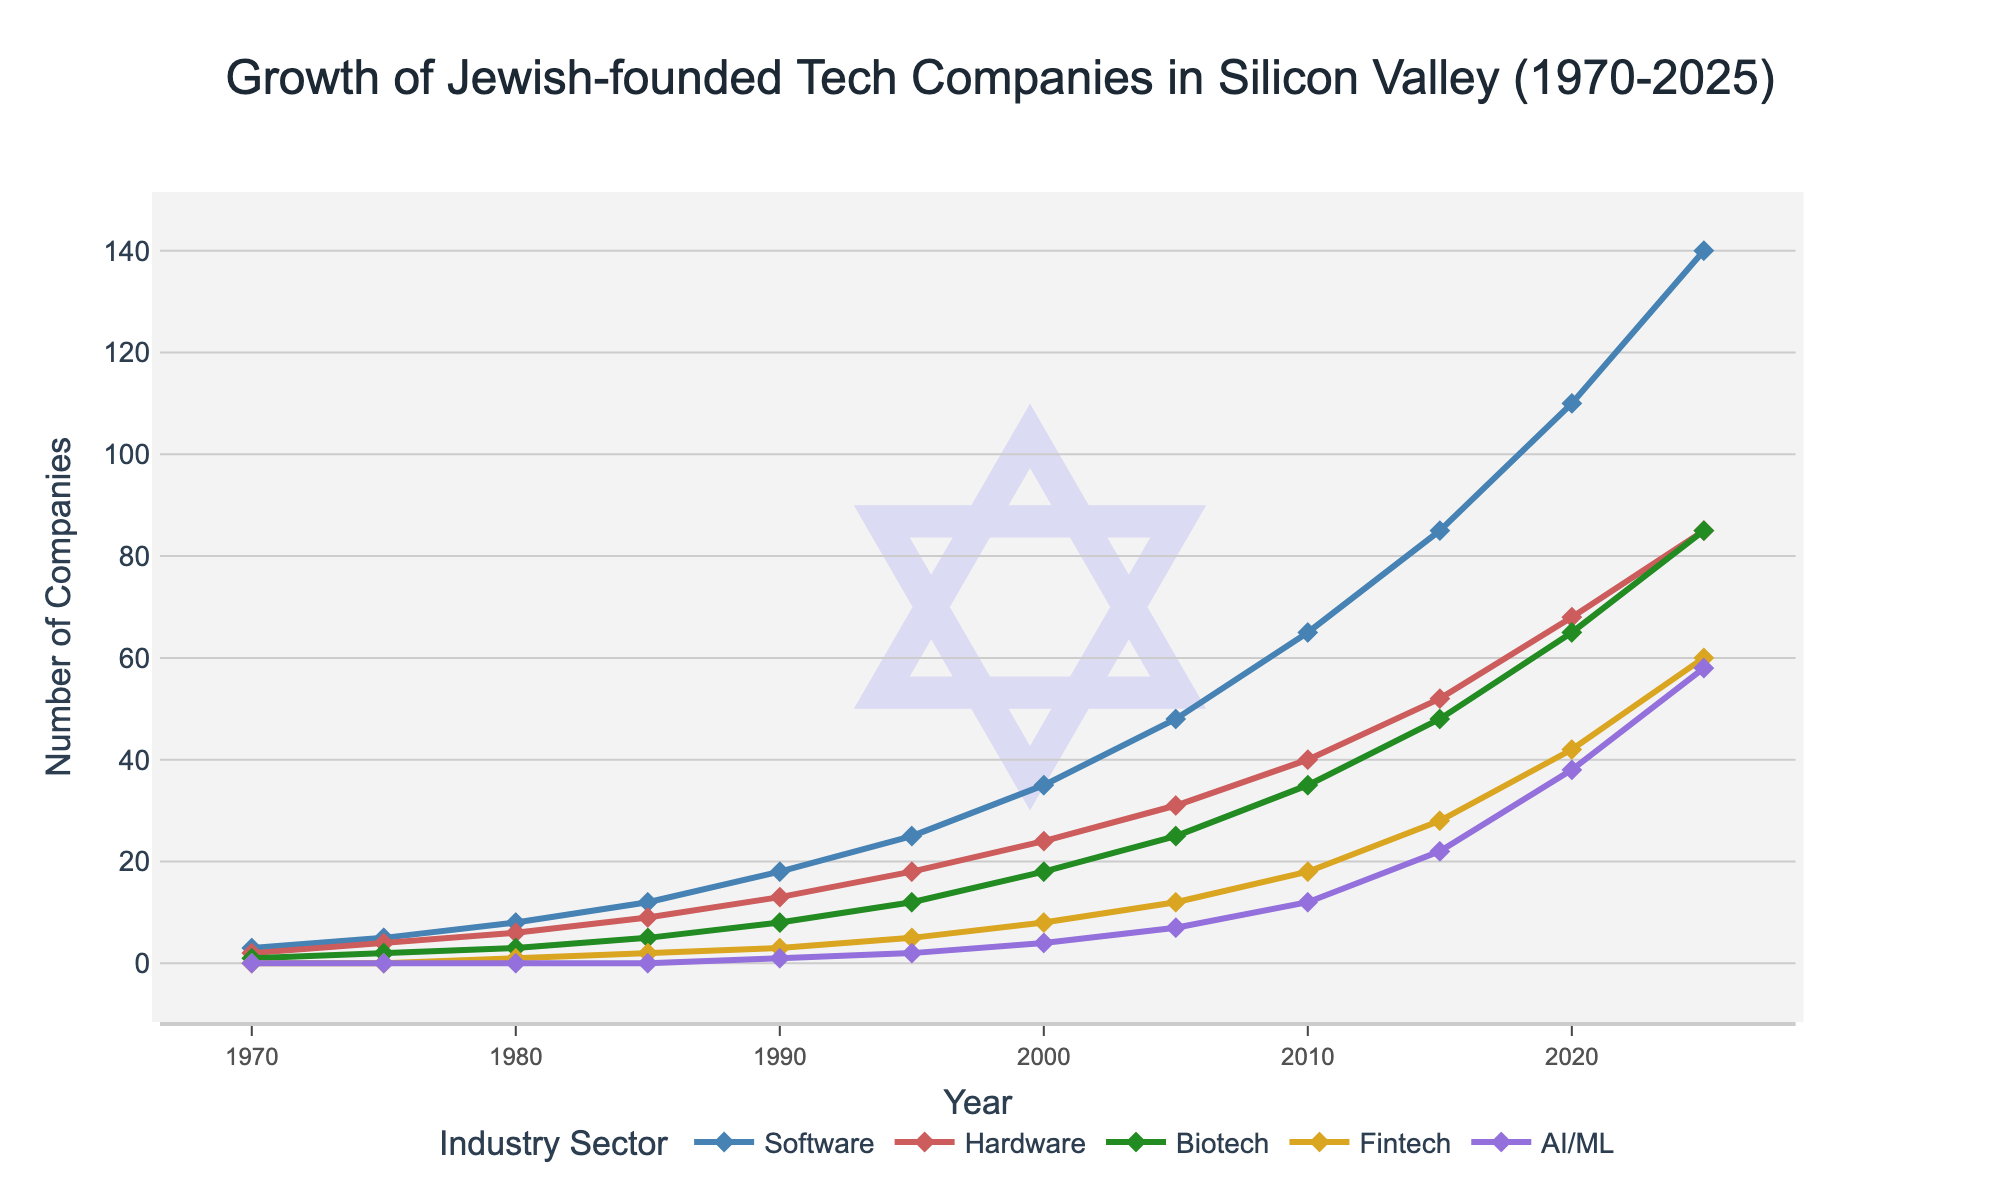What is the trend for software companies from 1970 to 2025? The software companies show a clear increasing trend from 1970 to 2025. In 1970, there are only 3 companies, while by 2025, the number reaches 140. This continuous growth indicates a steady expansion in the number of Jewish-founded software companies over the years.
Answer: Increasing trend How many sectors were represented by Jewish-founded companies in 1980? By visually detecting the presence of lines in 1980, we see markers for Software, Hardware, Biotech, and Fintech. The AI/ML sector starts later, and thus is absent. Summing up, 4 sectors were present: Software, Hardware, Biotech, and Fintech.
Answer: 4 Which industry sector had the highest growth rate from 2000 to 2025? By comparing the slopes of the lines from 2000 to 2025, AI/ML had the steepest increase in numbers (from 4 to 58), indicating the highest growth rate.
Answer: AI/ML Compare the number of hardware and biotech companies in 2010. In the year 2010, the number of hardware companies is 40 and the number of biotech companies is 35. Comparing these numbers, there are more hardware companies than biotech companies in 2010.
Answer: Hardware (40 vs 35) What is the total number of companies founded in 2020 across all sectors? Adding the numbers for each sector in 2020: 110 (Software) + 68 (Hardware) + 65 (Biotech) + 42 (Fintech) + 38 (AI/ML) gives a total of 323 companies.
Answer: 323 Which sector shows the first instance of Jewish-founded companies, and in what year? Observing the start years for each line, Software and Hardware are the first with activity in 1970 (3 and 2 companies, respectively). They share the same start year.
Answer: Software and Hardware, 1970 Is there any year where two sectors have an equal number of companies? If so, when and which sectors? By looking at the markers, in 2025, both Hardware and Biotech sectors have exactly 85 companies, making it the year when two sectors are equal.
Answer: 2025, Hardware and Biotech Which sector's growth appears the most exponential from 1970 to 2025? Software's line appears to curve upwards more compared to the others, suggesting exponential-like growth. From 3 companies in 1970 to 140 in 2025, it shows significant accelerative growth.
Answer: Software How does the number of fintech companies in 2005 compare to AI/ML companies in 2025? Fintech in 2005 has 12 companies, while AI/ML in 2025 has 58 companies. Clearly, AI/ML in 2025 outnumbers Fintech in 2005.
Answer: AI/ML (58 vs 12) What is the difference in the number of software companies between 1990 and 2020? The number of software companies in 1990 is 18, and in 2020 is 110. The difference is calculated as 110 - 18 = 92.
Answer: 92 